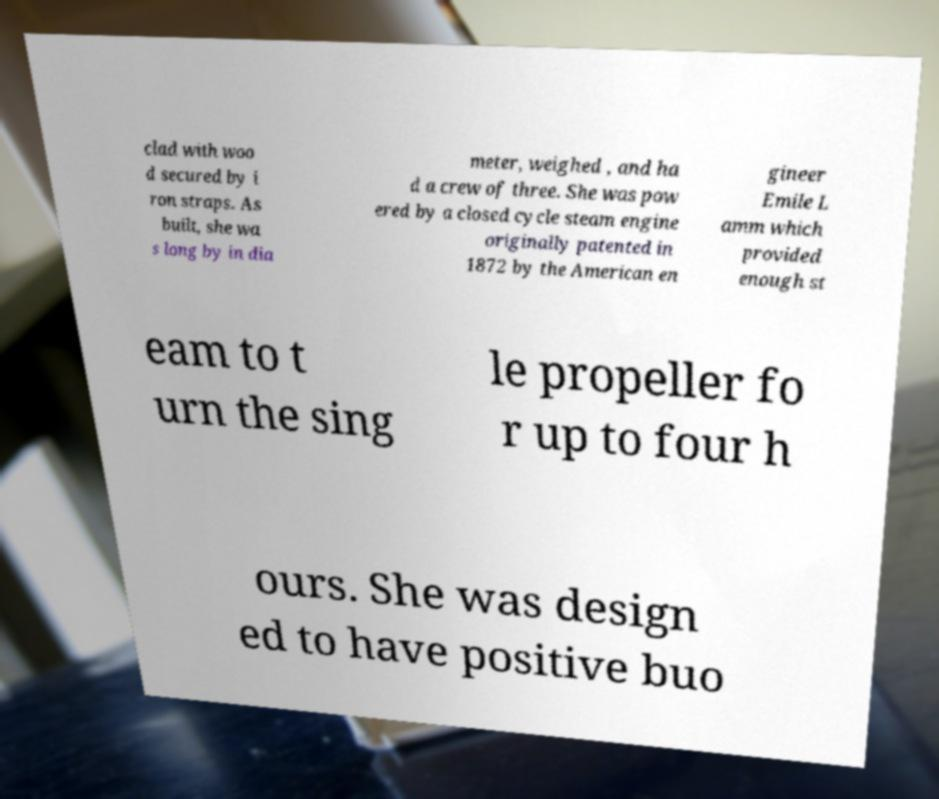Could you assist in decoding the text presented in this image and type it out clearly? clad with woo d secured by i ron straps. As built, she wa s long by in dia meter, weighed , and ha d a crew of three. She was pow ered by a closed cycle steam engine originally patented in 1872 by the American en gineer Emile L amm which provided enough st eam to t urn the sing le propeller fo r up to four h ours. She was design ed to have positive buo 